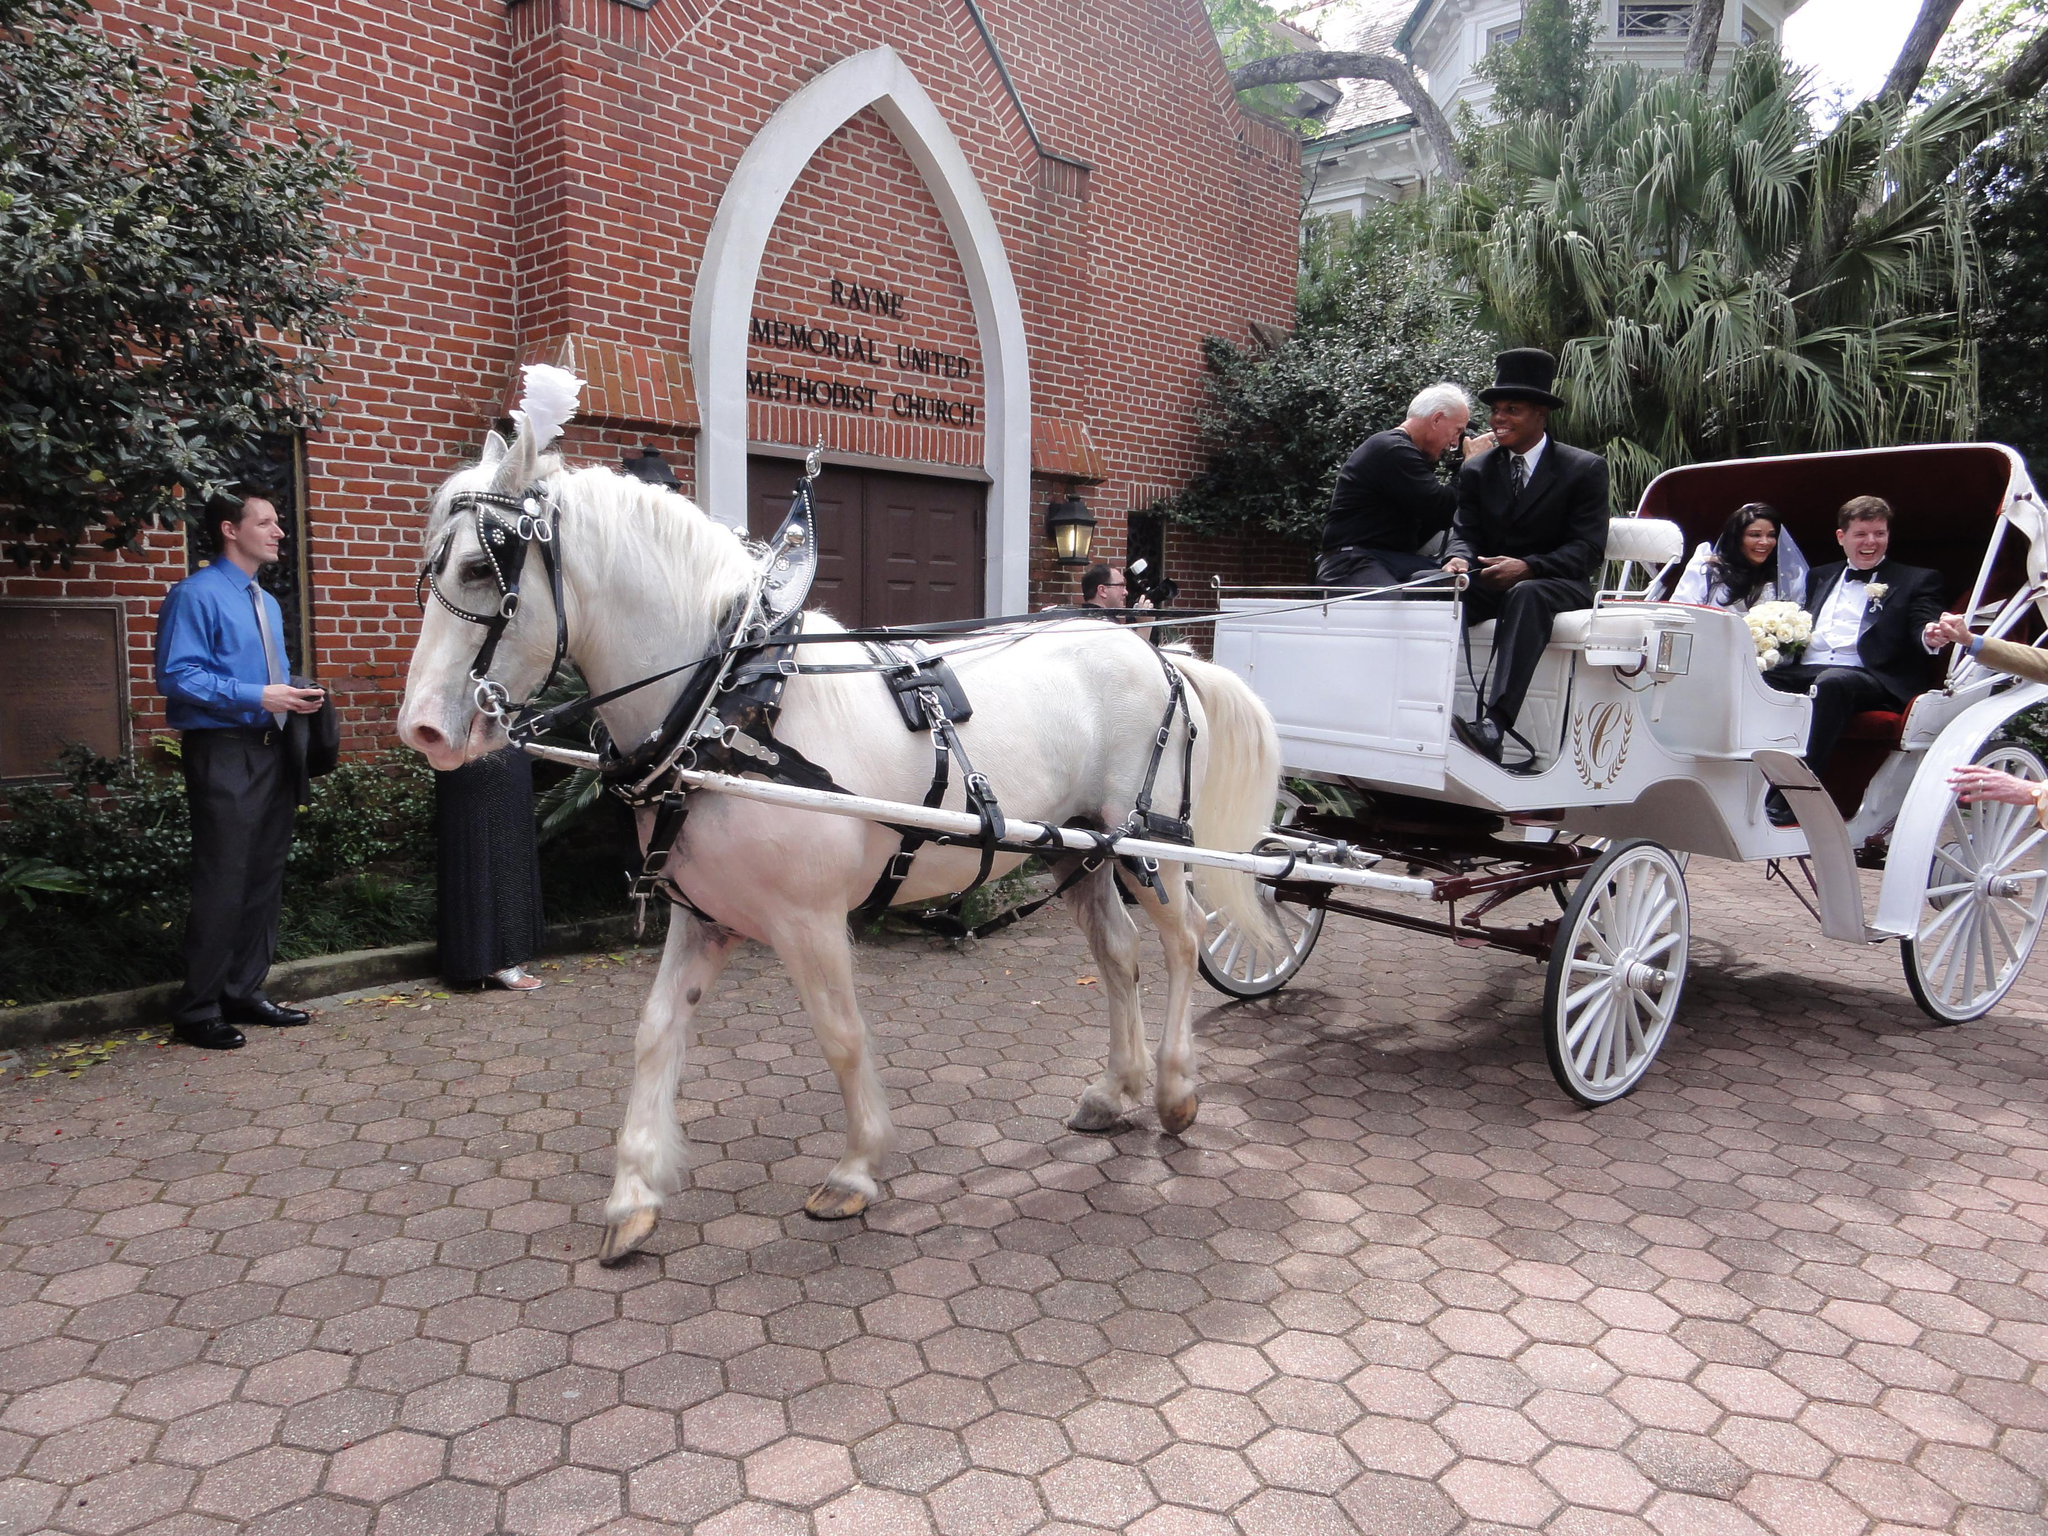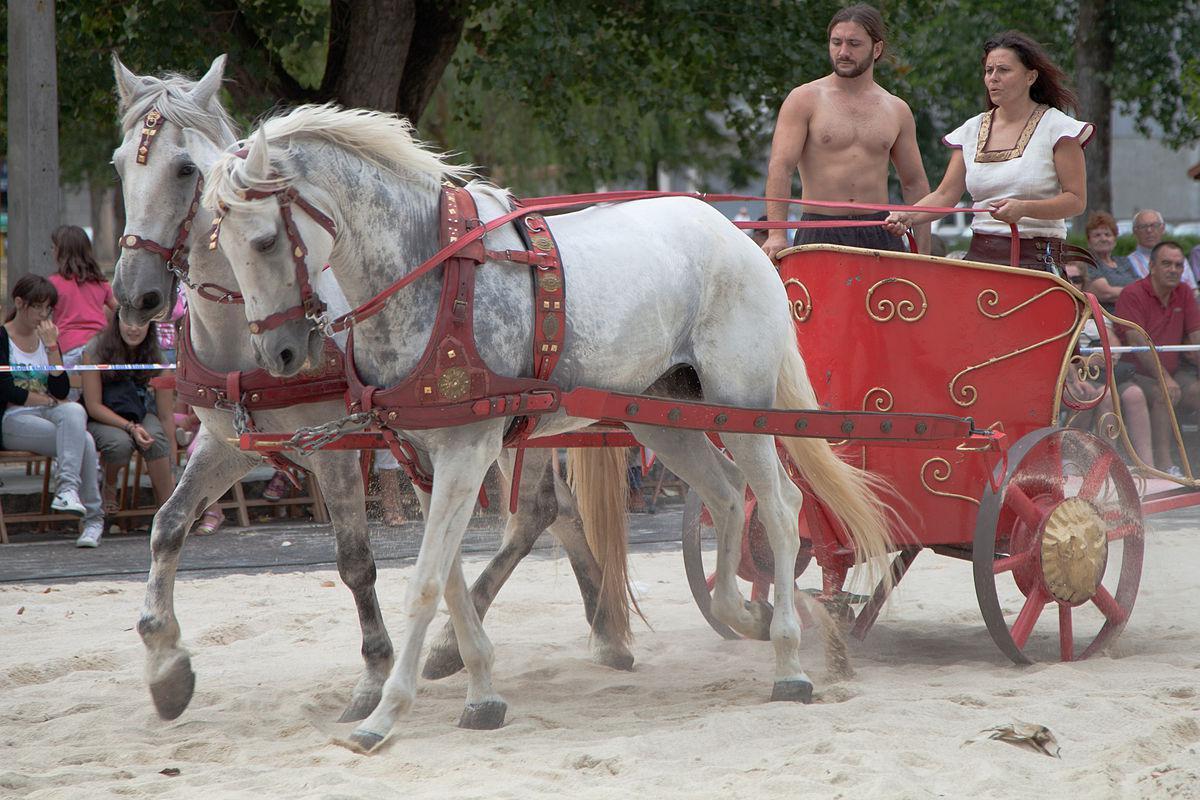The first image is the image on the left, the second image is the image on the right. For the images displayed, is the sentence "At least one image shows a cart pulled by four horses." factually correct? Answer yes or no. No. The first image is the image on the left, the second image is the image on the right. For the images shown, is this caption "There are brown horses shown in at least one of the images." true? Answer yes or no. No. 